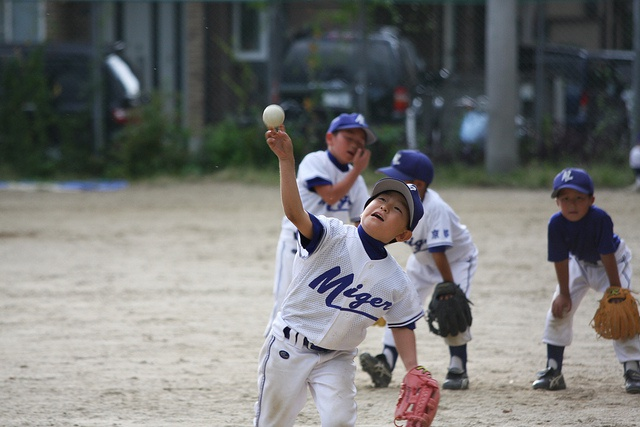Describe the objects in this image and their specific colors. I can see people in black, darkgray, lavender, and gray tones, people in black, darkgray, gray, and maroon tones, car in black, gray, and darkblue tones, people in black, darkgray, and gray tones, and car in black, gray, and purple tones in this image. 